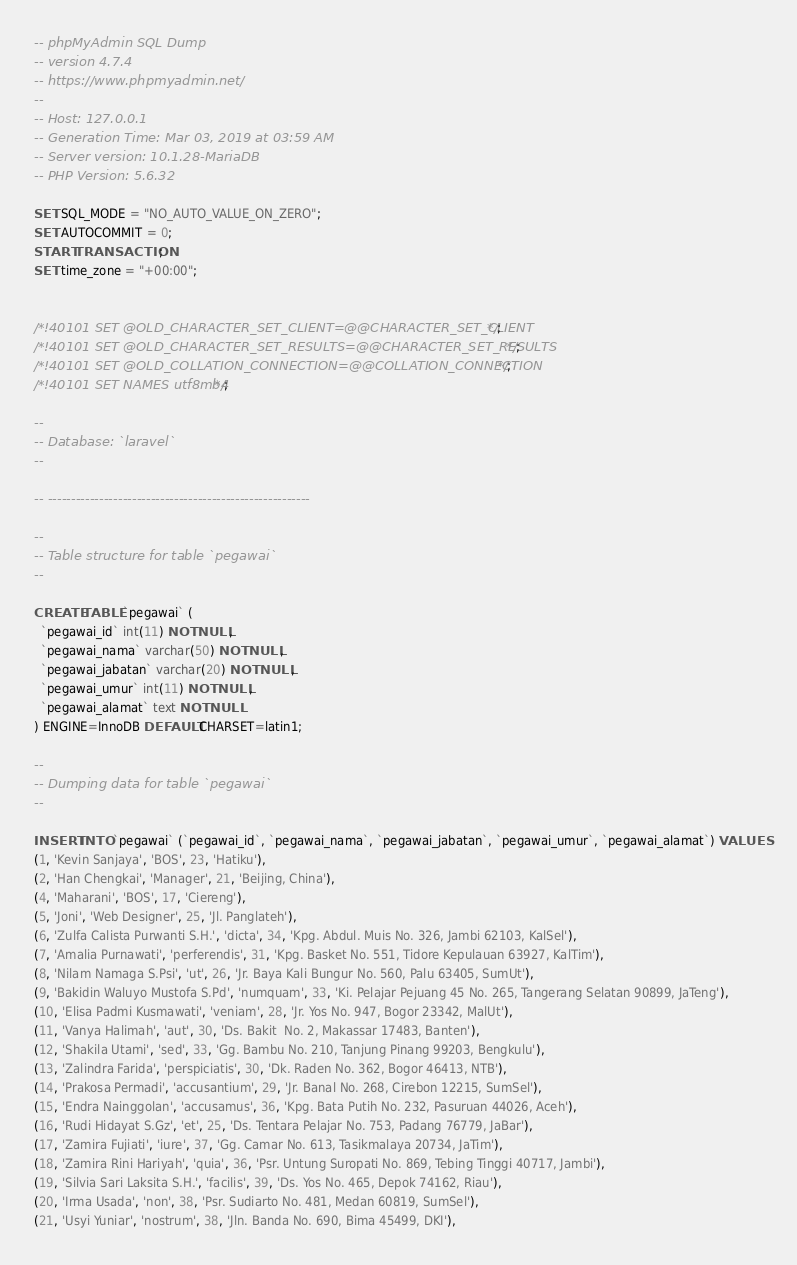Convert code to text. <code><loc_0><loc_0><loc_500><loc_500><_SQL_>-- phpMyAdmin SQL Dump
-- version 4.7.4
-- https://www.phpmyadmin.net/
--
-- Host: 127.0.0.1
-- Generation Time: Mar 03, 2019 at 03:59 AM
-- Server version: 10.1.28-MariaDB
-- PHP Version: 5.6.32

SET SQL_MODE = "NO_AUTO_VALUE_ON_ZERO";
SET AUTOCOMMIT = 0;
START TRANSACTION;
SET time_zone = "+00:00";


/*!40101 SET @OLD_CHARACTER_SET_CLIENT=@@CHARACTER_SET_CLIENT */;
/*!40101 SET @OLD_CHARACTER_SET_RESULTS=@@CHARACTER_SET_RESULTS */;
/*!40101 SET @OLD_COLLATION_CONNECTION=@@COLLATION_CONNECTION */;
/*!40101 SET NAMES utf8mb4 */;

--
-- Database: `laravel`
--

-- --------------------------------------------------------

--
-- Table structure for table `pegawai`
--

CREATE TABLE `pegawai` (
  `pegawai_id` int(11) NOT NULL,
  `pegawai_nama` varchar(50) NOT NULL,
  `pegawai_jabatan` varchar(20) NOT NULL,
  `pegawai_umur` int(11) NOT NULL,
  `pegawai_alamat` text NOT NULL
) ENGINE=InnoDB DEFAULT CHARSET=latin1;

--
-- Dumping data for table `pegawai`
--

INSERT INTO `pegawai` (`pegawai_id`, `pegawai_nama`, `pegawai_jabatan`, `pegawai_umur`, `pegawai_alamat`) VALUES
(1, 'Kevin Sanjaya', 'BOS', 23, 'Hatiku'),
(2, 'Han Chengkai', 'Manager', 21, 'Beijing, China'),
(4, 'Maharani', 'BOS', 17, 'Ciereng'),
(5, 'Joni', 'Web Designer', 25, 'Jl. Panglateh'),
(6, 'Zulfa Calista Purwanti S.H.', 'dicta', 34, 'Kpg. Abdul. Muis No. 326, Jambi 62103, KalSel'),
(7, 'Amalia Purnawati', 'perferendis', 31, 'Kpg. Basket No. 551, Tidore Kepulauan 63927, KalTim'),
(8, 'Nilam Namaga S.Psi', 'ut', 26, 'Jr. Baya Kali Bungur No. 560, Palu 63405, SumUt'),
(9, 'Bakidin Waluyo Mustofa S.Pd', 'numquam', 33, 'Ki. Pelajar Pejuang 45 No. 265, Tangerang Selatan 90899, JaTeng'),
(10, 'Elisa Padmi Kusmawati', 'veniam', 28, 'Jr. Yos No. 947, Bogor 23342, MalUt'),
(11, 'Vanya Halimah', 'aut', 30, 'Ds. Bakit  No. 2, Makassar 17483, Banten'),
(12, 'Shakila Utami', 'sed', 33, 'Gg. Bambu No. 210, Tanjung Pinang 99203, Bengkulu'),
(13, 'Zalindra Farida', 'perspiciatis', 30, 'Dk. Raden No. 362, Bogor 46413, NTB'),
(14, 'Prakosa Permadi', 'accusantium', 29, 'Jr. Banal No. 268, Cirebon 12215, SumSel'),
(15, 'Endra Nainggolan', 'accusamus', 36, 'Kpg. Bata Putih No. 232, Pasuruan 44026, Aceh'),
(16, 'Rudi Hidayat S.Gz', 'et', 25, 'Ds. Tentara Pelajar No. 753, Padang 76779, JaBar'),
(17, 'Zamira Fujiati', 'iure', 37, 'Gg. Camar No. 613, Tasikmalaya 20734, JaTim'),
(18, 'Zamira Rini Hariyah', 'quia', 36, 'Psr. Untung Suropati No. 869, Tebing Tinggi 40717, Jambi'),
(19, 'Silvia Sari Laksita S.H.', 'facilis', 39, 'Ds. Yos No. 465, Depok 74162, Riau'),
(20, 'Irma Usada', 'non', 38, 'Psr. Sudiarto No. 481, Medan 60819, SumSel'),
(21, 'Usyi Yuniar', 'nostrum', 38, 'Jln. Banda No. 690, Bima 45499, DKI'),</code> 